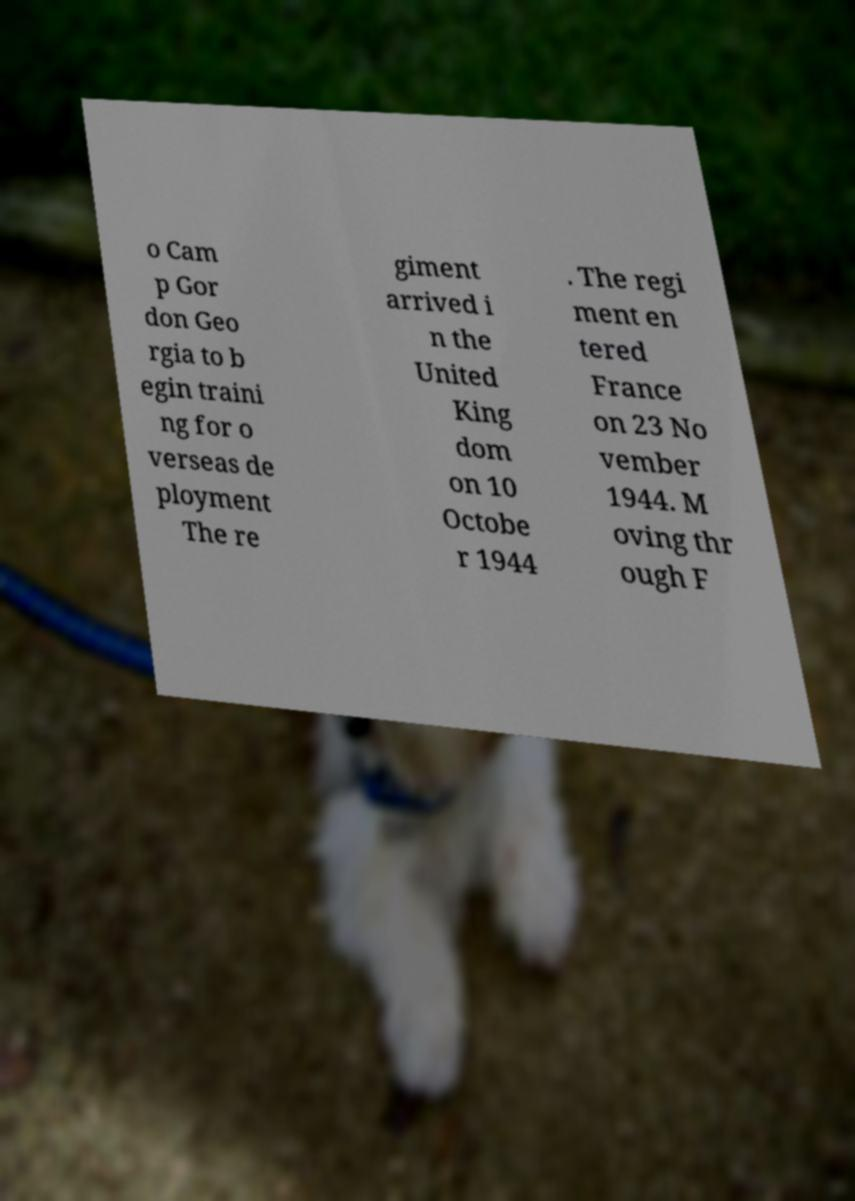Can you read and provide the text displayed in the image?This photo seems to have some interesting text. Can you extract and type it out for me? o Cam p Gor don Geo rgia to b egin traini ng for o verseas de ployment The re giment arrived i n the United King dom on 10 Octobe r 1944 . The regi ment en tered France on 23 No vember 1944. M oving thr ough F 